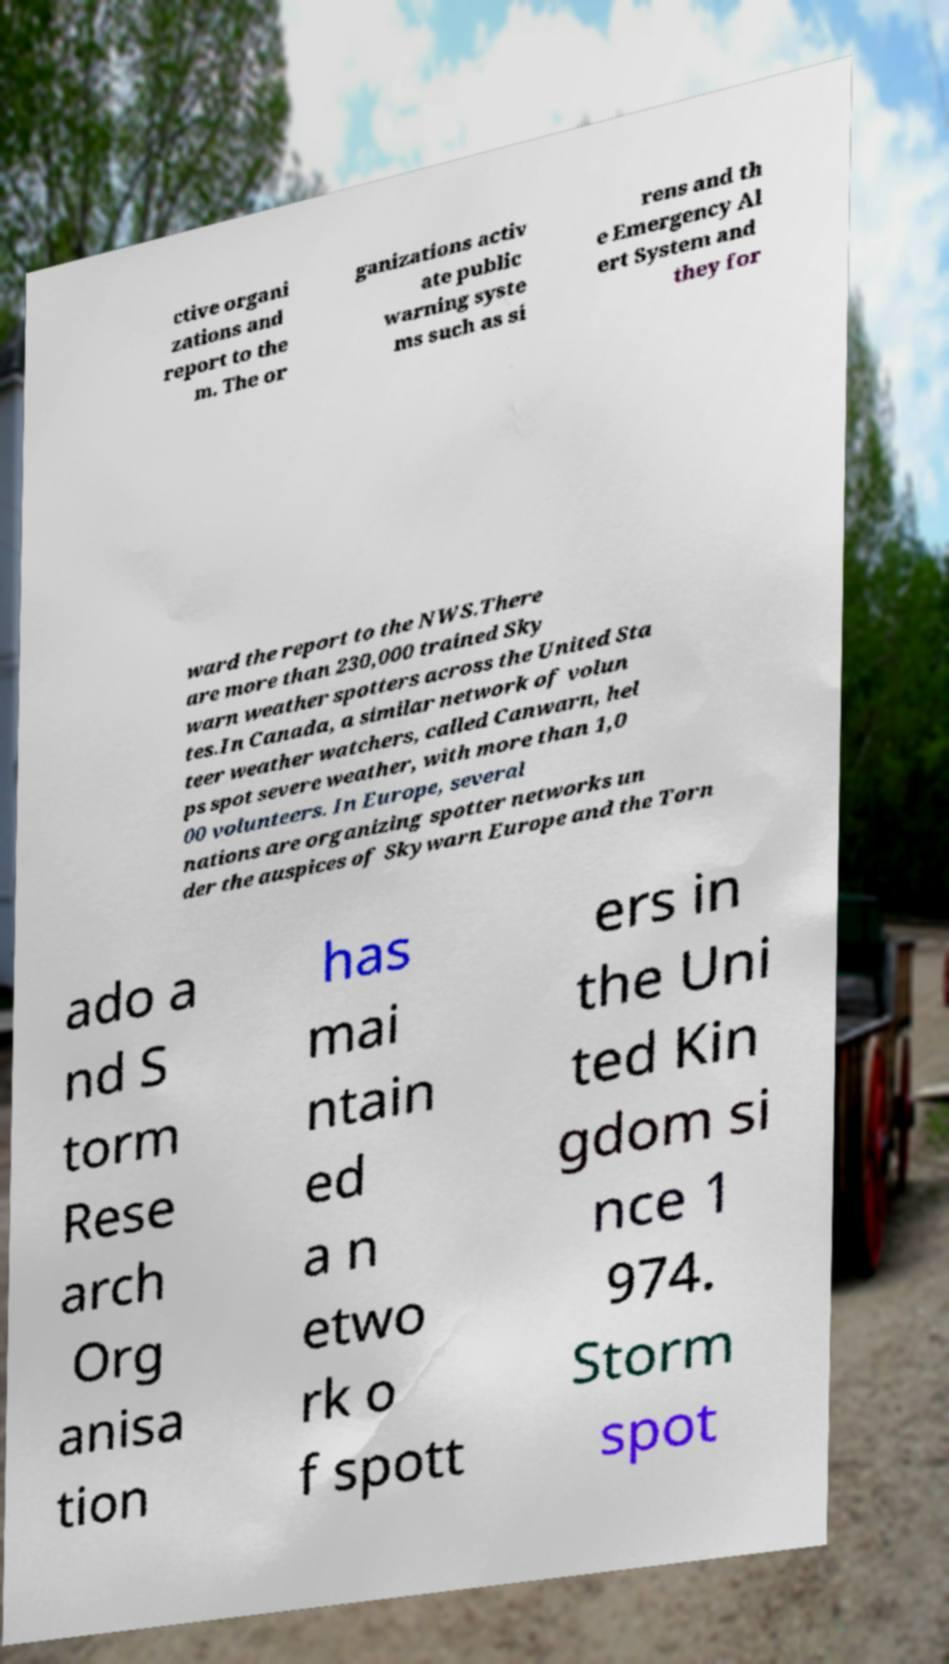Please identify and transcribe the text found in this image. ctive organi zations and report to the m. The or ganizations activ ate public warning syste ms such as si rens and th e Emergency Al ert System and they for ward the report to the NWS.There are more than 230,000 trained Sky warn weather spotters across the United Sta tes.In Canada, a similar network of volun teer weather watchers, called Canwarn, hel ps spot severe weather, with more than 1,0 00 volunteers. In Europe, several nations are organizing spotter networks un der the auspices of Skywarn Europe and the Torn ado a nd S torm Rese arch Org anisa tion has mai ntain ed a n etwo rk o f spott ers in the Uni ted Kin gdom si nce 1 974. Storm spot 